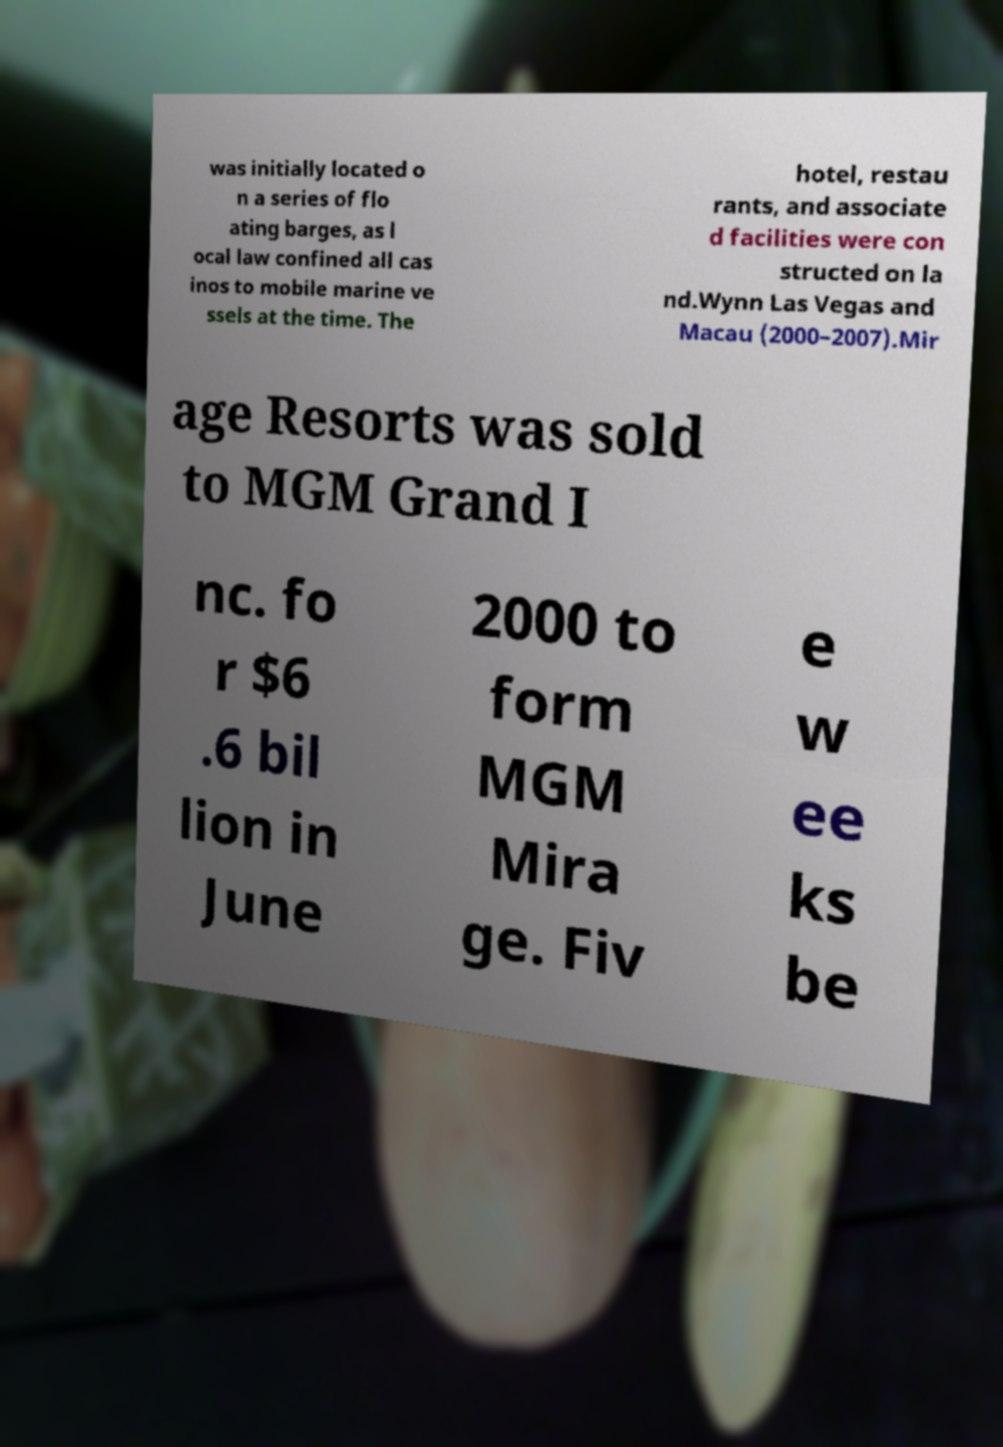Please read and relay the text visible in this image. What does it say? was initially located o n a series of flo ating barges, as l ocal law confined all cas inos to mobile marine ve ssels at the time. The hotel, restau rants, and associate d facilities were con structed on la nd.Wynn Las Vegas and Macau (2000–2007).Mir age Resorts was sold to MGM Grand I nc. fo r $6 .6 bil lion in June 2000 to form MGM Mira ge. Fiv e w ee ks be 